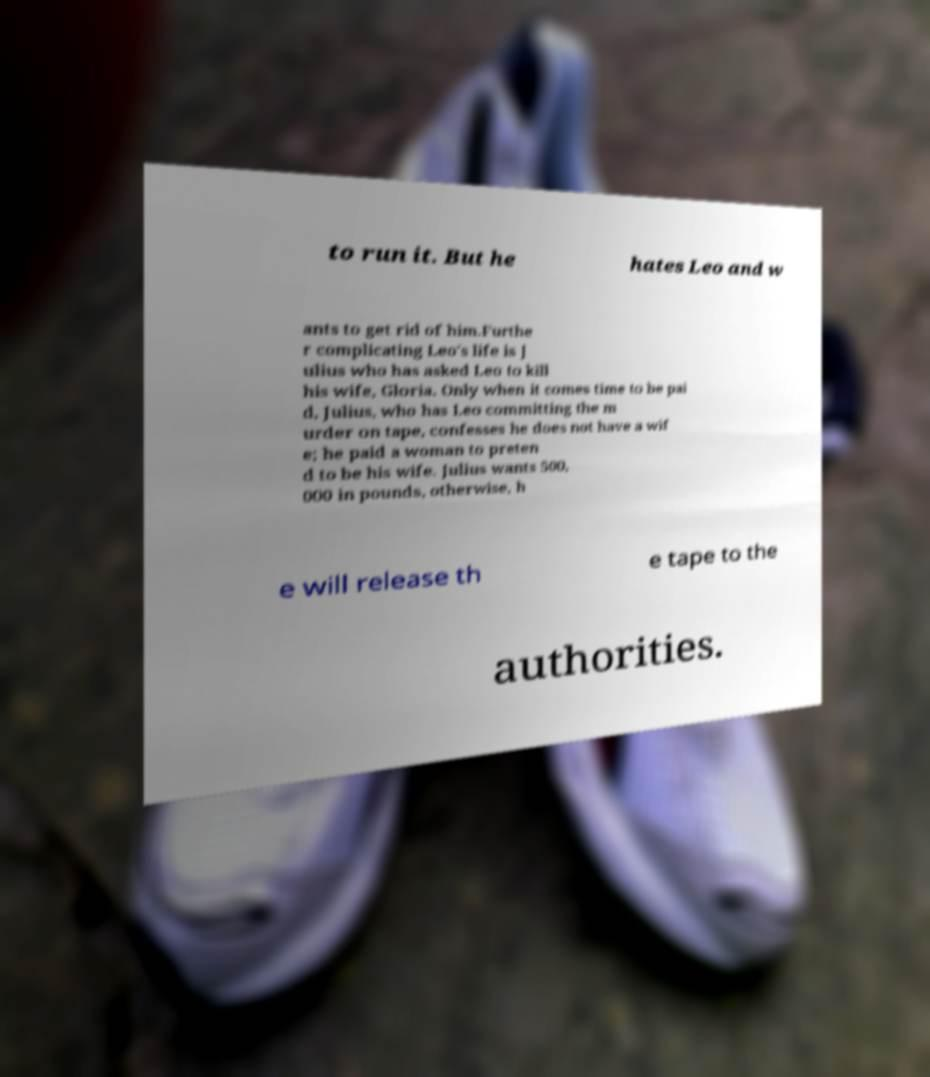Could you extract and type out the text from this image? to run it. But he hates Leo and w ants to get rid of him.Furthe r complicating Leo's life is J ulius who has asked Leo to kill his wife, Gloria. Only when it comes time to be pai d, Julius, who has Leo committing the m urder on tape, confesses he does not have a wif e; he paid a woman to preten d to be his wife. Julius wants 500, 000 in pounds, otherwise, h e will release th e tape to the authorities. 